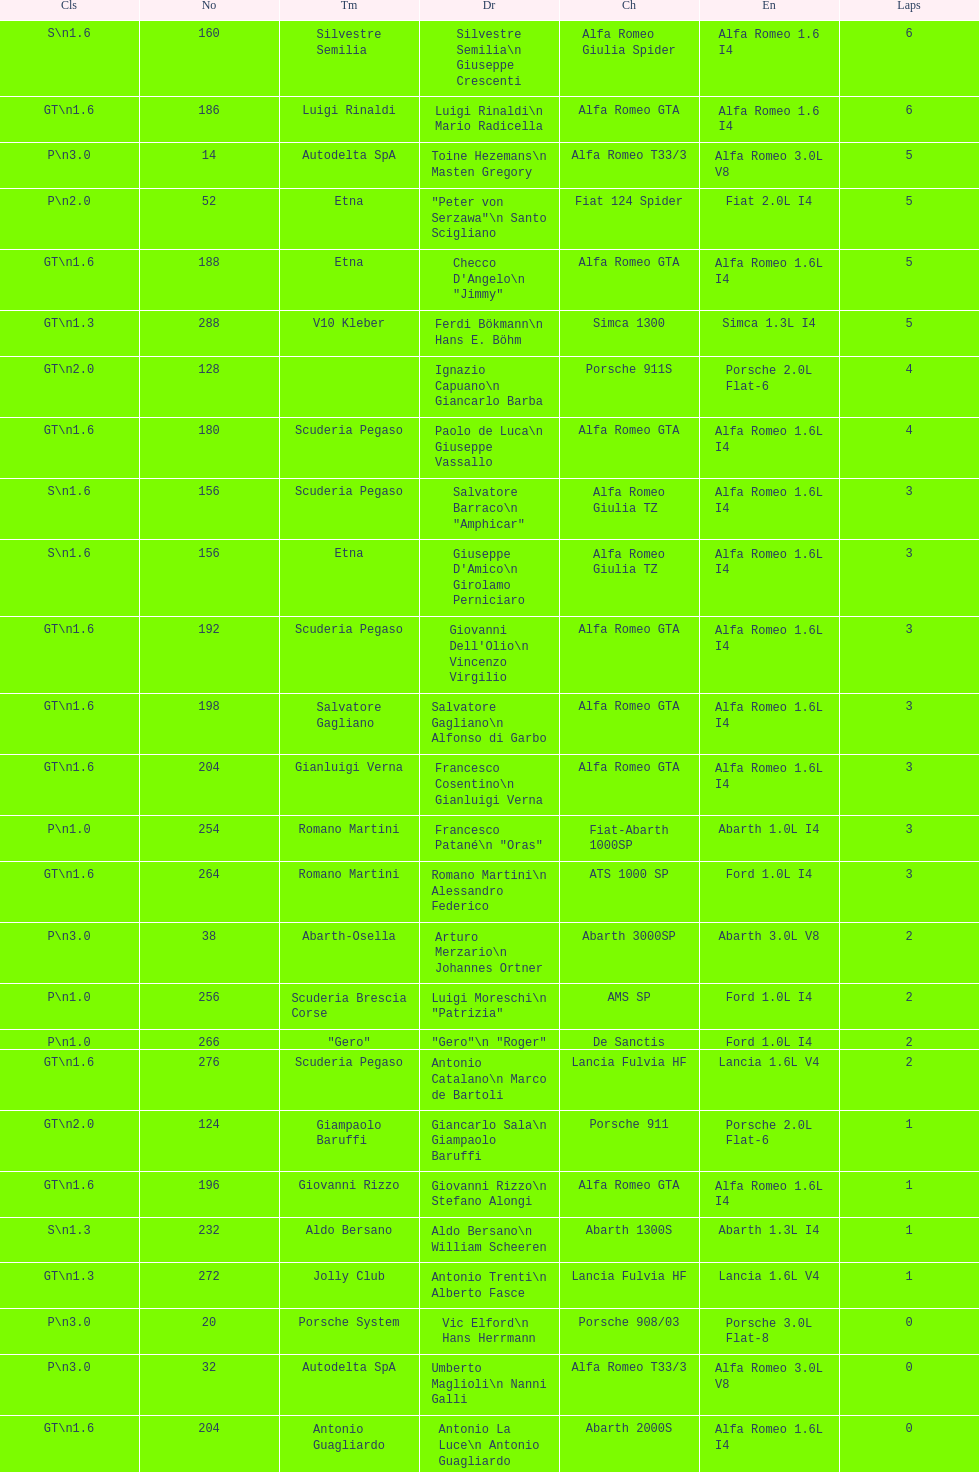How many teams failed to finish the race after 2 laps? 4. 